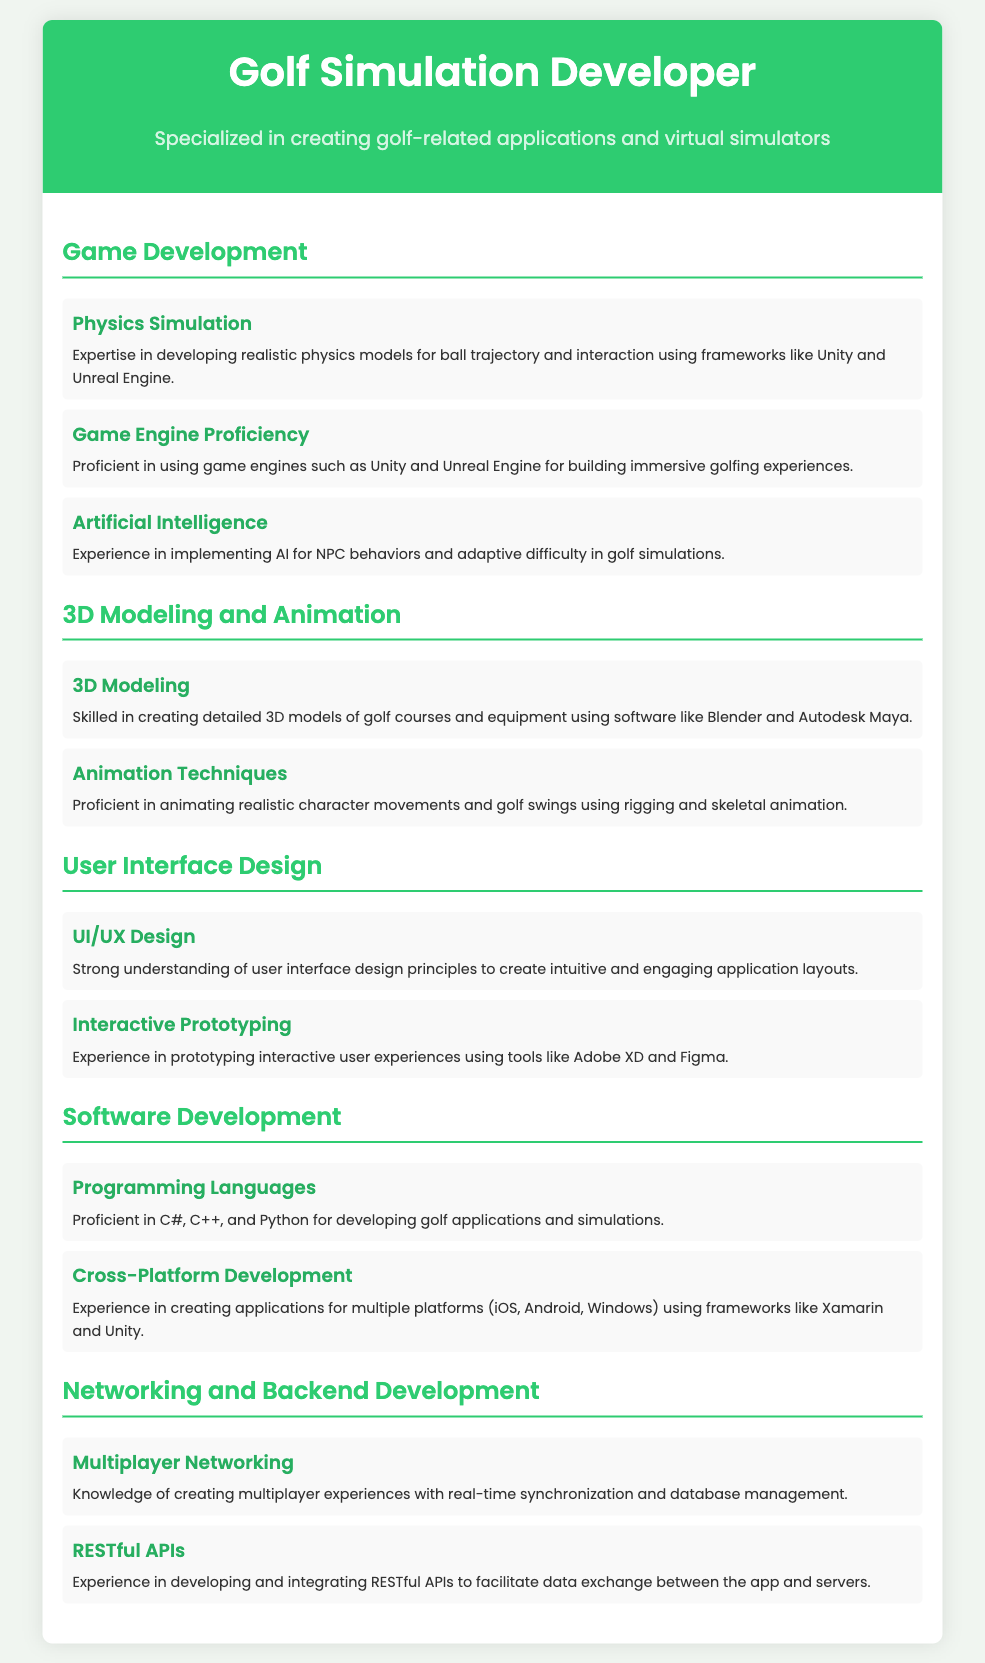What is the title of the CV? The title of the CV is displayed prominently at the top of the document in a large font.
Answer: Golf Simulation Developer What programming languages is the developer proficient in? The CV lists specific programming languages under the Software Development section.
Answer: C#, C++, and Python Which software is mentioned for 3D modeling? The CV identifies the software tools used for creating 3D models in the 3D Modeling and Animation section.
Answer: Blender and Autodesk Maya How many sections are there in the skills matrix? By counting the distinct headings in the skills category, we determine the number of sections.
Answer: Five What is a skill related to user interface design? The CV mentions specific skills under User Interface Design, such as UI/UX Design.
Answer: UI/UX Design Which game engines does the developer use? The document lists game engines that the developer is proficient in the Game Development section.
Answer: Unity and Unreal Engine What is the focus of the curriculum? The overall theme of the CV is indicated in the subtitle that describes the specialization.
Answer: Creating golf-related applications and virtual simulators What type of networking experience does the developer have? The CV specifies a skill set related to networking in the Networking and Backend Development section.
Answer: Multiplayer Networking What tools are used for interactive prototyping? The CV lists tools related to UI/UX design mentioning prototyping.
Answer: Adobe XD and Figma 